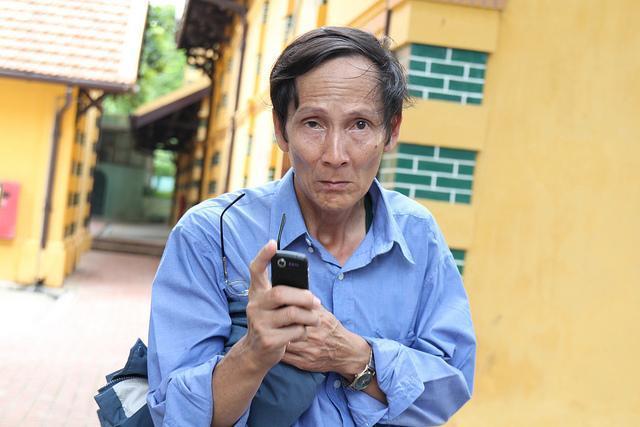How many cows are in this picture?
Give a very brief answer. 0. 